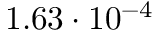<formula> <loc_0><loc_0><loc_500><loc_500>1 . 6 3 \cdot 1 0 ^ { - 4 }</formula> 